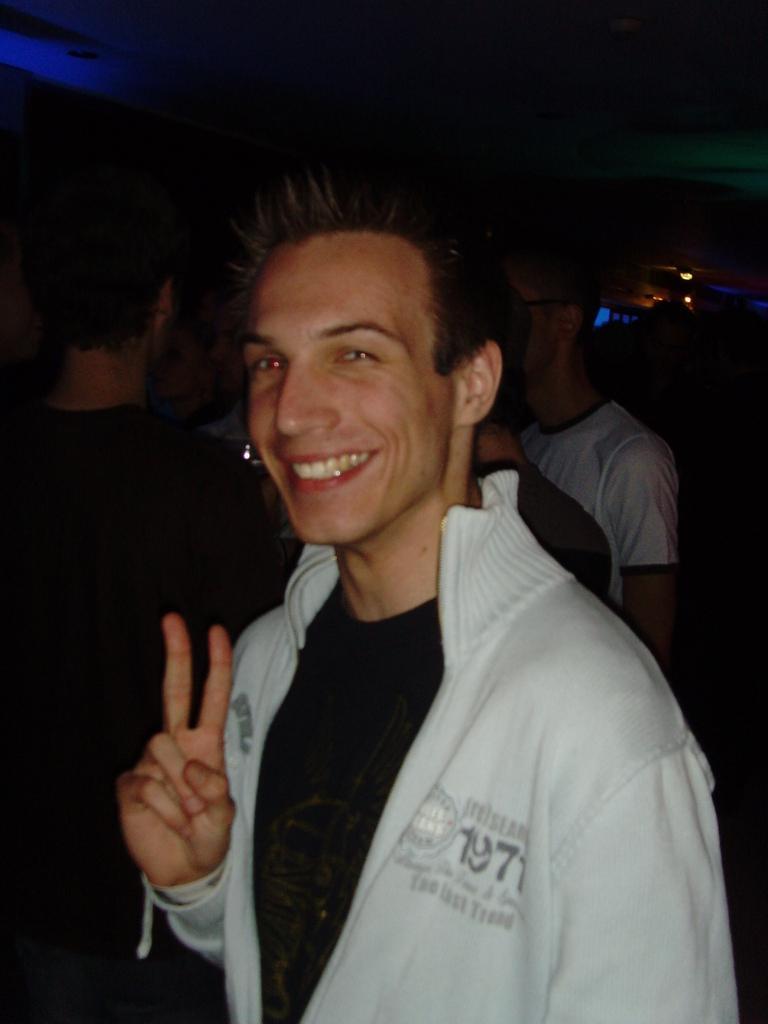Can you describe this image briefly? In this picture we can see a man smiling and at the back of him we can see some people standing, lights and in the background it is dark. 